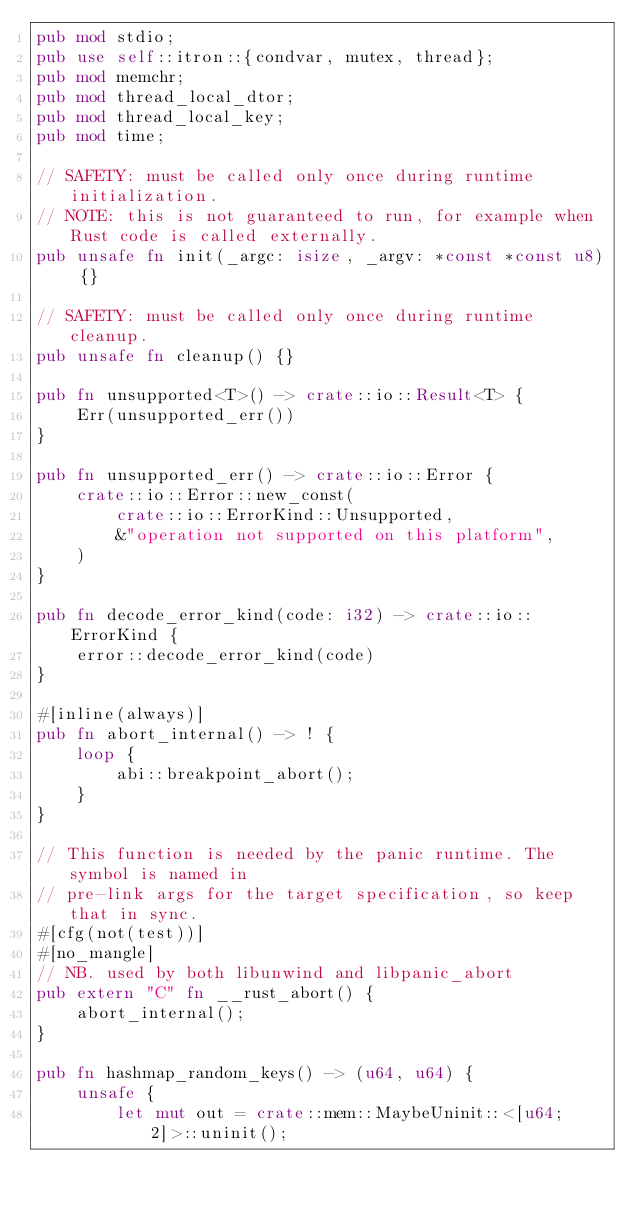Convert code to text. <code><loc_0><loc_0><loc_500><loc_500><_Rust_>pub mod stdio;
pub use self::itron::{condvar, mutex, thread};
pub mod memchr;
pub mod thread_local_dtor;
pub mod thread_local_key;
pub mod time;

// SAFETY: must be called only once during runtime initialization.
// NOTE: this is not guaranteed to run, for example when Rust code is called externally.
pub unsafe fn init(_argc: isize, _argv: *const *const u8) {}

// SAFETY: must be called only once during runtime cleanup.
pub unsafe fn cleanup() {}

pub fn unsupported<T>() -> crate::io::Result<T> {
    Err(unsupported_err())
}

pub fn unsupported_err() -> crate::io::Error {
    crate::io::Error::new_const(
        crate::io::ErrorKind::Unsupported,
        &"operation not supported on this platform",
    )
}

pub fn decode_error_kind(code: i32) -> crate::io::ErrorKind {
    error::decode_error_kind(code)
}

#[inline(always)]
pub fn abort_internal() -> ! {
    loop {
        abi::breakpoint_abort();
    }
}

// This function is needed by the panic runtime. The symbol is named in
// pre-link args for the target specification, so keep that in sync.
#[cfg(not(test))]
#[no_mangle]
// NB. used by both libunwind and libpanic_abort
pub extern "C" fn __rust_abort() {
    abort_internal();
}

pub fn hashmap_random_keys() -> (u64, u64) {
    unsafe {
        let mut out = crate::mem::MaybeUninit::<[u64; 2]>::uninit();</code> 